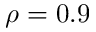Convert formula to latex. <formula><loc_0><loc_0><loc_500><loc_500>\rho = 0 . 9</formula> 